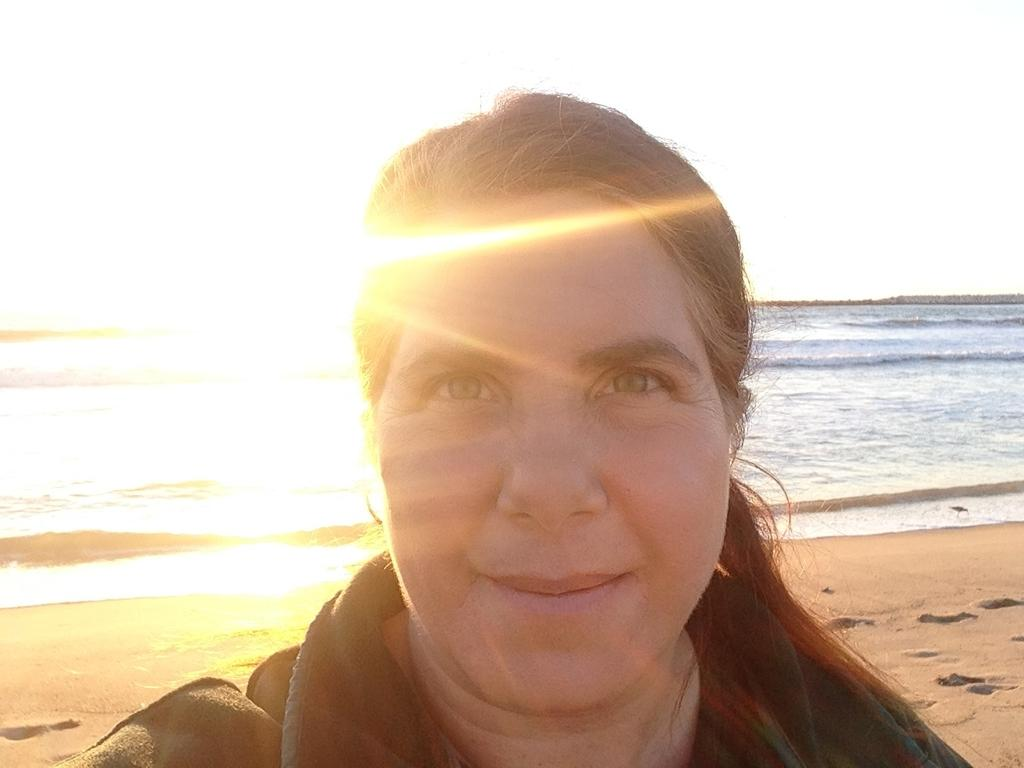Who is the main subject in the foreground of the image? There is a woman in the foreground of the image. What type of environment is depicted in the background of the image? There is sand, water, sunlight, and the sky visible in the background of the image. What type of dust can be seen on the woman's clothes in the image? There is no dust visible on the woman's clothes in the image. How many pails are being used by the woman in the image? There is no pail present in the image. 